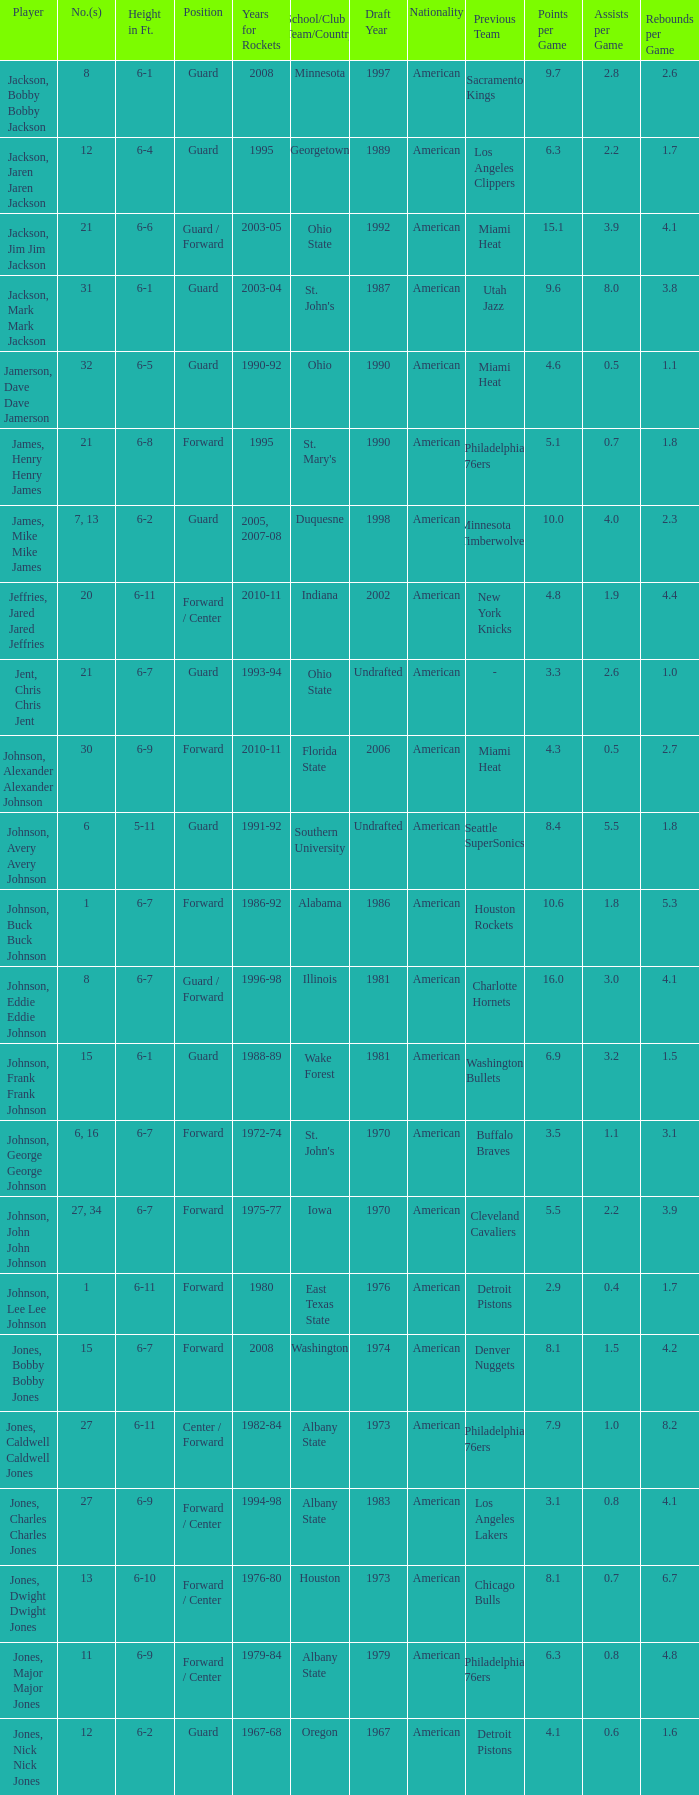What is the number of the player who went to Southern University? 6.0. 